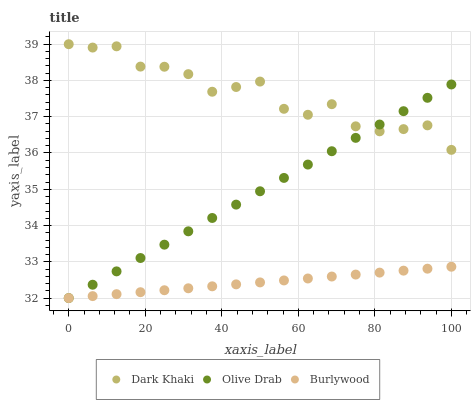Does Burlywood have the minimum area under the curve?
Answer yes or no. Yes. Does Dark Khaki have the maximum area under the curve?
Answer yes or no. Yes. Does Olive Drab have the minimum area under the curve?
Answer yes or no. No. Does Olive Drab have the maximum area under the curve?
Answer yes or no. No. Is Burlywood the smoothest?
Answer yes or no. Yes. Is Dark Khaki the roughest?
Answer yes or no. Yes. Is Olive Drab the smoothest?
Answer yes or no. No. Is Olive Drab the roughest?
Answer yes or no. No. Does Burlywood have the lowest value?
Answer yes or no. Yes. Does Dark Khaki have the highest value?
Answer yes or no. Yes. Does Olive Drab have the highest value?
Answer yes or no. No. Is Burlywood less than Dark Khaki?
Answer yes or no. Yes. Is Dark Khaki greater than Burlywood?
Answer yes or no. Yes. Does Olive Drab intersect Burlywood?
Answer yes or no. Yes. Is Olive Drab less than Burlywood?
Answer yes or no. No. Is Olive Drab greater than Burlywood?
Answer yes or no. No. Does Burlywood intersect Dark Khaki?
Answer yes or no. No. 